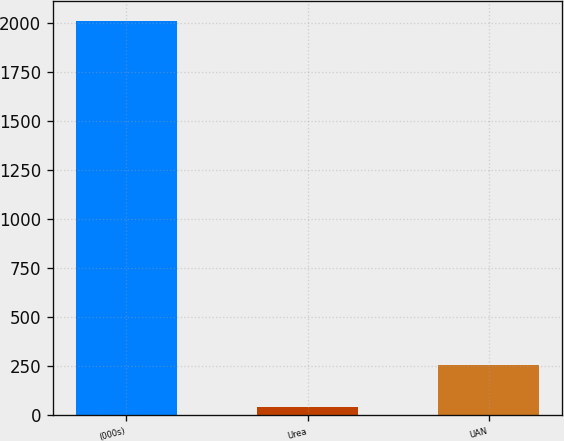<chart> <loc_0><loc_0><loc_500><loc_500><bar_chart><fcel>(000s)<fcel>Urea<fcel>UAN<nl><fcel>2010<fcel>41<fcel>257<nl></chart> 